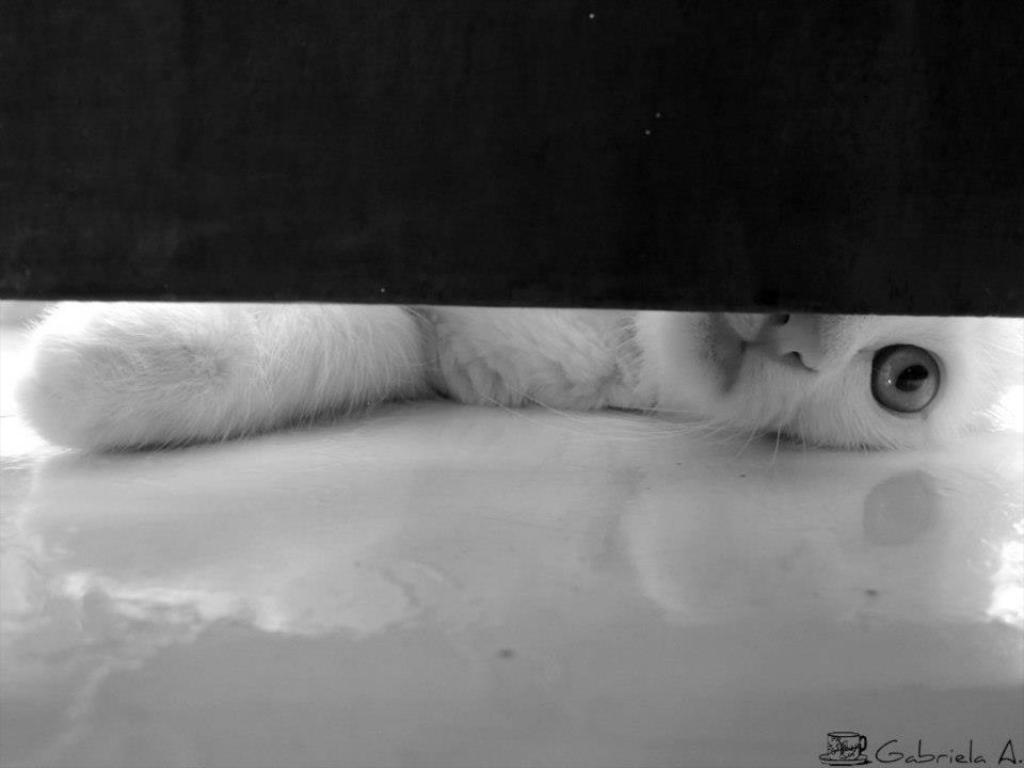In one or two sentences, can you explain what this image depicts? In this image there is floor towards the bottom of the image, there is a cat lying on the floor, there is text towards the bottom of the image, there is a cup towards the bottom of the image, there is a saucer towards the bottom of the image, the top of the image is dark. 